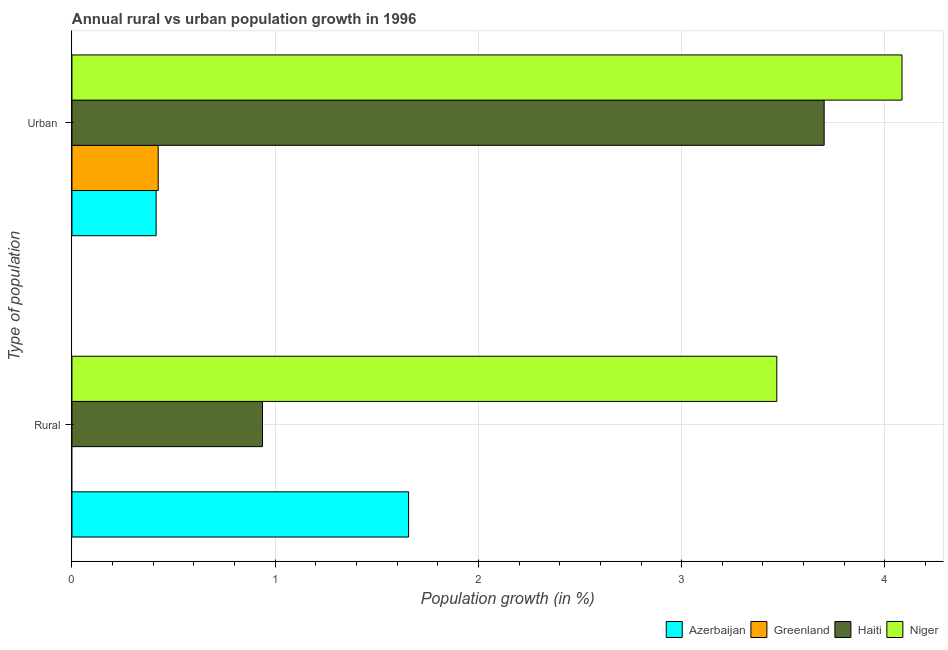How many different coloured bars are there?
Provide a succinct answer. 4. Are the number of bars per tick equal to the number of legend labels?
Offer a terse response. No. Are the number of bars on each tick of the Y-axis equal?
Keep it short and to the point. No. How many bars are there on the 2nd tick from the top?
Offer a very short reply. 3. What is the label of the 1st group of bars from the top?
Your answer should be compact. Urban . What is the urban population growth in Haiti?
Offer a terse response. 3.7. Across all countries, what is the maximum urban population growth?
Provide a succinct answer. 4.08. In which country was the urban population growth maximum?
Offer a terse response. Niger. What is the total rural population growth in the graph?
Keep it short and to the point. 6.06. What is the difference between the urban population growth in Haiti and that in Greenland?
Your response must be concise. 3.28. What is the difference between the urban population growth in Azerbaijan and the rural population growth in Niger?
Ensure brevity in your answer.  -3.05. What is the average rural population growth per country?
Give a very brief answer. 1.52. What is the difference between the urban population growth and rural population growth in Azerbaijan?
Ensure brevity in your answer.  -1.24. What is the ratio of the urban population growth in Azerbaijan to that in Haiti?
Your answer should be compact. 0.11. In how many countries, is the urban population growth greater than the average urban population growth taken over all countries?
Ensure brevity in your answer.  2. Are all the bars in the graph horizontal?
Offer a terse response. Yes. How many countries are there in the graph?
Keep it short and to the point. 4. Does the graph contain grids?
Keep it short and to the point. Yes. How many legend labels are there?
Offer a very short reply. 4. How are the legend labels stacked?
Your answer should be compact. Horizontal. What is the title of the graph?
Your response must be concise. Annual rural vs urban population growth in 1996. Does "Nigeria" appear as one of the legend labels in the graph?
Your response must be concise. No. What is the label or title of the X-axis?
Offer a terse response. Population growth (in %). What is the label or title of the Y-axis?
Your answer should be compact. Type of population. What is the Population growth (in %) of Azerbaijan in Rural?
Your response must be concise. 1.66. What is the Population growth (in %) of Greenland in Rural?
Offer a very short reply. 0. What is the Population growth (in %) of Haiti in Rural?
Keep it short and to the point. 0.94. What is the Population growth (in %) of Niger in Rural?
Your answer should be compact. 3.47. What is the Population growth (in %) of Azerbaijan in Urban ?
Ensure brevity in your answer.  0.41. What is the Population growth (in %) of Greenland in Urban ?
Ensure brevity in your answer.  0.42. What is the Population growth (in %) of Haiti in Urban ?
Give a very brief answer. 3.7. What is the Population growth (in %) in Niger in Urban ?
Make the answer very short. 4.08. Across all Type of population, what is the maximum Population growth (in %) of Azerbaijan?
Provide a succinct answer. 1.66. Across all Type of population, what is the maximum Population growth (in %) of Greenland?
Provide a short and direct response. 0.42. Across all Type of population, what is the maximum Population growth (in %) in Haiti?
Provide a succinct answer. 3.7. Across all Type of population, what is the maximum Population growth (in %) of Niger?
Offer a very short reply. 4.08. Across all Type of population, what is the minimum Population growth (in %) in Azerbaijan?
Keep it short and to the point. 0.41. Across all Type of population, what is the minimum Population growth (in %) in Greenland?
Provide a short and direct response. 0. Across all Type of population, what is the minimum Population growth (in %) in Haiti?
Your answer should be very brief. 0.94. Across all Type of population, what is the minimum Population growth (in %) in Niger?
Provide a short and direct response. 3.47. What is the total Population growth (in %) in Azerbaijan in the graph?
Provide a succinct answer. 2.07. What is the total Population growth (in %) of Greenland in the graph?
Keep it short and to the point. 0.42. What is the total Population growth (in %) in Haiti in the graph?
Offer a terse response. 4.64. What is the total Population growth (in %) in Niger in the graph?
Give a very brief answer. 7.55. What is the difference between the Population growth (in %) in Azerbaijan in Rural and that in Urban ?
Offer a very short reply. 1.24. What is the difference between the Population growth (in %) of Haiti in Rural and that in Urban ?
Offer a very short reply. -2.76. What is the difference between the Population growth (in %) of Niger in Rural and that in Urban ?
Your answer should be very brief. -0.62. What is the difference between the Population growth (in %) of Azerbaijan in Rural and the Population growth (in %) of Greenland in Urban ?
Your response must be concise. 1.23. What is the difference between the Population growth (in %) in Azerbaijan in Rural and the Population growth (in %) in Haiti in Urban ?
Keep it short and to the point. -2.04. What is the difference between the Population growth (in %) in Azerbaijan in Rural and the Population growth (in %) in Niger in Urban ?
Offer a terse response. -2.43. What is the difference between the Population growth (in %) in Haiti in Rural and the Population growth (in %) in Niger in Urban ?
Your response must be concise. -3.15. What is the average Population growth (in %) in Azerbaijan per Type of population?
Ensure brevity in your answer.  1.04. What is the average Population growth (in %) of Greenland per Type of population?
Provide a succinct answer. 0.21. What is the average Population growth (in %) of Haiti per Type of population?
Give a very brief answer. 2.32. What is the average Population growth (in %) in Niger per Type of population?
Your answer should be very brief. 3.78. What is the difference between the Population growth (in %) of Azerbaijan and Population growth (in %) of Haiti in Rural?
Keep it short and to the point. 0.72. What is the difference between the Population growth (in %) in Azerbaijan and Population growth (in %) in Niger in Rural?
Offer a terse response. -1.81. What is the difference between the Population growth (in %) in Haiti and Population growth (in %) in Niger in Rural?
Offer a very short reply. -2.53. What is the difference between the Population growth (in %) of Azerbaijan and Population growth (in %) of Greenland in Urban ?
Provide a succinct answer. -0.01. What is the difference between the Population growth (in %) of Azerbaijan and Population growth (in %) of Haiti in Urban ?
Provide a short and direct response. -3.29. What is the difference between the Population growth (in %) in Azerbaijan and Population growth (in %) in Niger in Urban ?
Offer a very short reply. -3.67. What is the difference between the Population growth (in %) in Greenland and Population growth (in %) in Haiti in Urban ?
Ensure brevity in your answer.  -3.28. What is the difference between the Population growth (in %) of Greenland and Population growth (in %) of Niger in Urban ?
Your response must be concise. -3.66. What is the difference between the Population growth (in %) in Haiti and Population growth (in %) in Niger in Urban ?
Make the answer very short. -0.38. What is the ratio of the Population growth (in %) in Azerbaijan in Rural to that in Urban ?
Your response must be concise. 4. What is the ratio of the Population growth (in %) of Haiti in Rural to that in Urban ?
Provide a short and direct response. 0.25. What is the ratio of the Population growth (in %) in Niger in Rural to that in Urban ?
Ensure brevity in your answer.  0.85. What is the difference between the highest and the second highest Population growth (in %) of Azerbaijan?
Offer a terse response. 1.24. What is the difference between the highest and the second highest Population growth (in %) in Haiti?
Give a very brief answer. 2.76. What is the difference between the highest and the second highest Population growth (in %) of Niger?
Keep it short and to the point. 0.62. What is the difference between the highest and the lowest Population growth (in %) in Azerbaijan?
Your answer should be compact. 1.24. What is the difference between the highest and the lowest Population growth (in %) in Greenland?
Offer a terse response. 0.42. What is the difference between the highest and the lowest Population growth (in %) of Haiti?
Give a very brief answer. 2.76. What is the difference between the highest and the lowest Population growth (in %) of Niger?
Your answer should be very brief. 0.62. 